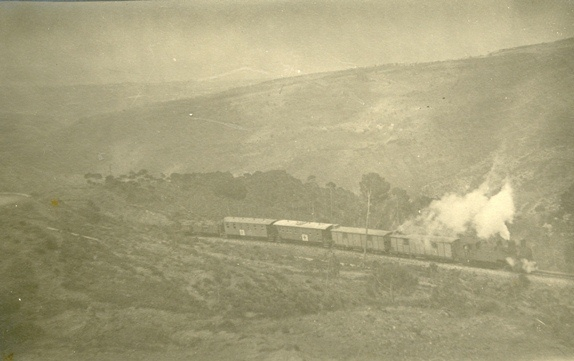Describe the objects in this image and their specific colors. I can see a train in gray and tan tones in this image. 